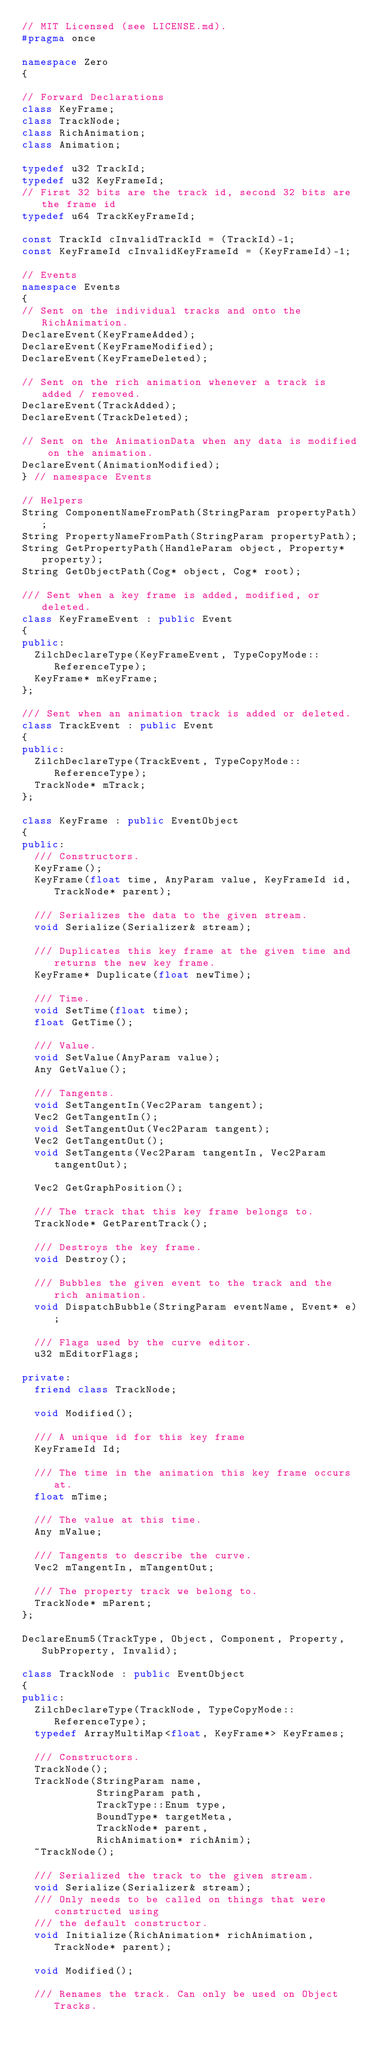<code> <loc_0><loc_0><loc_500><loc_500><_C++_>// MIT Licensed (see LICENSE.md).
#pragma once

namespace Zero
{

// Forward Declarations
class KeyFrame;
class TrackNode;
class RichAnimation;
class Animation;

typedef u32 TrackId;
typedef u32 KeyFrameId;
// First 32 bits are the track id, second 32 bits are the frame id
typedef u64 TrackKeyFrameId;

const TrackId cInvalidTrackId = (TrackId)-1;
const KeyFrameId cInvalidKeyFrameId = (KeyFrameId)-1;

// Events
namespace Events
{
// Sent on the individual tracks and onto the RichAnimation.
DeclareEvent(KeyFrameAdded);
DeclareEvent(KeyFrameModified);
DeclareEvent(KeyFrameDeleted);

// Sent on the rich animation whenever a track is added / removed.
DeclareEvent(TrackAdded);
DeclareEvent(TrackDeleted);

// Sent on the AnimationData when any data is modified on the animation.
DeclareEvent(AnimationModified);
} // namespace Events

// Helpers
String ComponentNameFromPath(StringParam propertyPath);
String PropertyNameFromPath(StringParam propertyPath);
String GetPropertyPath(HandleParam object, Property* property);
String GetObjectPath(Cog* object, Cog* root);

/// Sent when a key frame is added, modified, or deleted.
class KeyFrameEvent : public Event
{
public:
  ZilchDeclareType(KeyFrameEvent, TypeCopyMode::ReferenceType);
  KeyFrame* mKeyFrame;
};

/// Sent when an animation track is added or deleted.
class TrackEvent : public Event
{
public:
  ZilchDeclareType(TrackEvent, TypeCopyMode::ReferenceType);
  TrackNode* mTrack;
};

class KeyFrame : public EventObject
{
public:
  /// Constructors.
  KeyFrame();
  KeyFrame(float time, AnyParam value, KeyFrameId id, TrackNode* parent);

  /// Serializes the data to the given stream.
  void Serialize(Serializer& stream);

  /// Duplicates this key frame at the given time and returns the new key frame.
  KeyFrame* Duplicate(float newTime);

  /// Time.
  void SetTime(float time);
  float GetTime();

  /// Value.
  void SetValue(AnyParam value);
  Any GetValue();

  /// Tangents.
  void SetTangentIn(Vec2Param tangent);
  Vec2 GetTangentIn();
  void SetTangentOut(Vec2Param tangent);
  Vec2 GetTangentOut();
  void SetTangents(Vec2Param tangentIn, Vec2Param tangentOut);

  Vec2 GetGraphPosition();

  /// The track that this key frame belongs to.
  TrackNode* GetParentTrack();

  /// Destroys the key frame.
  void Destroy();

  /// Bubbles the given event to the track and the rich animation.
  void DispatchBubble(StringParam eventName, Event* e);

  /// Flags used by the curve editor.
  u32 mEditorFlags;

private:
  friend class TrackNode;

  void Modified();

  /// A unique id for this key frame
  KeyFrameId Id;

  /// The time in the animation this key frame occurs at.
  float mTime;

  /// The value at this time.
  Any mValue;

  /// Tangents to describe the curve.
  Vec2 mTangentIn, mTangentOut;

  /// The property track we belong to.
  TrackNode* mParent;
};

DeclareEnum5(TrackType, Object, Component, Property, SubProperty, Invalid);

class TrackNode : public EventObject
{
public:
  ZilchDeclareType(TrackNode, TypeCopyMode::ReferenceType);
  typedef ArrayMultiMap<float, KeyFrame*> KeyFrames;

  /// Constructors.
  TrackNode();
  TrackNode(StringParam name,
            StringParam path,
            TrackType::Enum type,
            BoundType* targetMeta,
            TrackNode* parent,
            RichAnimation* richAnim);
  ~TrackNode();

  /// Serialized the track to the given stream.
  void Serialize(Serializer& stream);
  /// Only needs to be called on things that were constructed using
  /// the default constructor.
  void Initialize(RichAnimation* richAnimation, TrackNode* parent);

  void Modified();

  /// Renames the track. Can only be used on Object Tracks.</code> 